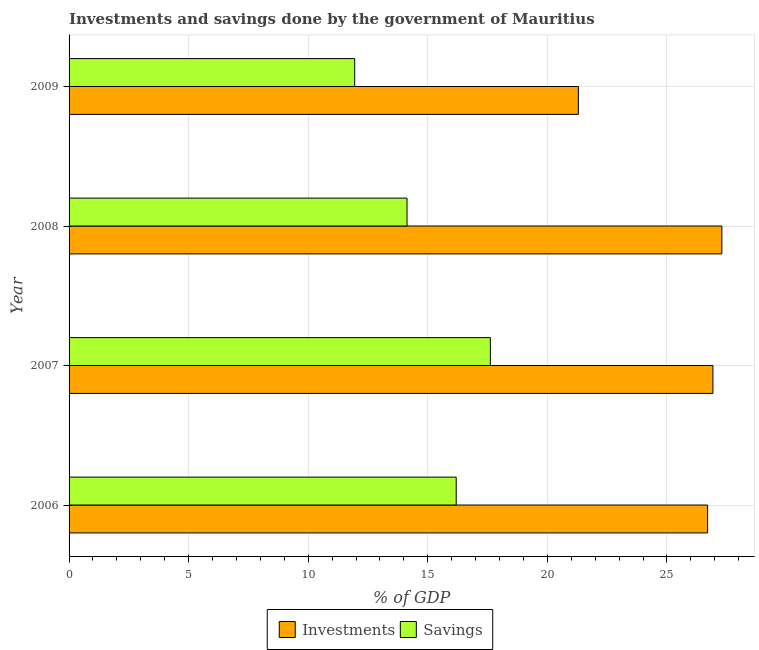How many different coloured bars are there?
Ensure brevity in your answer.  2. In how many cases, is the number of bars for a given year not equal to the number of legend labels?
Your answer should be very brief. 0. What is the investments of government in 2007?
Provide a short and direct response. 26.92. Across all years, what is the maximum savings of government?
Keep it short and to the point. 17.62. Across all years, what is the minimum investments of government?
Give a very brief answer. 21.3. In which year was the savings of government maximum?
Your answer should be compact. 2007. What is the total savings of government in the graph?
Your answer should be very brief. 59.88. What is the difference between the savings of government in 2006 and that in 2008?
Offer a terse response. 2.06. What is the difference between the savings of government in 2008 and the investments of government in 2007?
Your answer should be very brief. -12.79. What is the average savings of government per year?
Give a very brief answer. 14.97. In the year 2009, what is the difference between the investments of government and savings of government?
Your answer should be very brief. 9.35. What is the ratio of the investments of government in 2007 to that in 2009?
Give a very brief answer. 1.26. Is the difference between the investments of government in 2008 and 2009 greater than the difference between the savings of government in 2008 and 2009?
Your response must be concise. Yes. What is the difference between the highest and the second highest savings of government?
Your response must be concise. 1.43. What is the difference between the highest and the lowest savings of government?
Your response must be concise. 5.67. In how many years, is the savings of government greater than the average savings of government taken over all years?
Give a very brief answer. 2. What does the 2nd bar from the top in 2006 represents?
Offer a very short reply. Investments. What does the 1st bar from the bottom in 2006 represents?
Give a very brief answer. Investments. How many bars are there?
Offer a very short reply. 8. Are all the bars in the graph horizontal?
Offer a terse response. Yes. How many years are there in the graph?
Make the answer very short. 4. Are the values on the major ticks of X-axis written in scientific E-notation?
Your response must be concise. No. Does the graph contain any zero values?
Ensure brevity in your answer.  No. Where does the legend appear in the graph?
Your answer should be very brief. Bottom center. How many legend labels are there?
Give a very brief answer. 2. What is the title of the graph?
Keep it short and to the point. Investments and savings done by the government of Mauritius. What is the label or title of the X-axis?
Provide a short and direct response. % of GDP. What is the label or title of the Y-axis?
Provide a succinct answer. Year. What is the % of GDP of Investments in 2006?
Offer a very short reply. 26.7. What is the % of GDP of Savings in 2006?
Provide a short and direct response. 16.19. What is the % of GDP in Investments in 2007?
Offer a very short reply. 26.92. What is the % of GDP in Savings in 2007?
Provide a short and direct response. 17.62. What is the % of GDP of Investments in 2008?
Provide a succinct answer. 27.3. What is the % of GDP of Savings in 2008?
Your response must be concise. 14.13. What is the % of GDP of Investments in 2009?
Keep it short and to the point. 21.3. What is the % of GDP of Savings in 2009?
Provide a succinct answer. 11.94. Across all years, what is the maximum % of GDP in Investments?
Provide a short and direct response. 27.3. Across all years, what is the maximum % of GDP in Savings?
Offer a very short reply. 17.62. Across all years, what is the minimum % of GDP in Investments?
Make the answer very short. 21.3. Across all years, what is the minimum % of GDP of Savings?
Your answer should be very brief. 11.94. What is the total % of GDP in Investments in the graph?
Provide a succinct answer. 102.22. What is the total % of GDP in Savings in the graph?
Your answer should be very brief. 59.88. What is the difference between the % of GDP of Investments in 2006 and that in 2007?
Give a very brief answer. -0.22. What is the difference between the % of GDP of Savings in 2006 and that in 2007?
Make the answer very short. -1.43. What is the difference between the % of GDP in Investments in 2006 and that in 2008?
Ensure brevity in your answer.  -0.6. What is the difference between the % of GDP of Savings in 2006 and that in 2008?
Provide a short and direct response. 2.06. What is the difference between the % of GDP of Investments in 2006 and that in 2009?
Your answer should be very brief. 5.4. What is the difference between the % of GDP of Savings in 2006 and that in 2009?
Offer a very short reply. 4.24. What is the difference between the % of GDP of Investments in 2007 and that in 2008?
Your answer should be compact. -0.37. What is the difference between the % of GDP of Savings in 2007 and that in 2008?
Your answer should be very brief. 3.48. What is the difference between the % of GDP of Investments in 2007 and that in 2009?
Keep it short and to the point. 5.63. What is the difference between the % of GDP of Savings in 2007 and that in 2009?
Your response must be concise. 5.67. What is the difference between the % of GDP in Investments in 2008 and that in 2009?
Ensure brevity in your answer.  6. What is the difference between the % of GDP of Savings in 2008 and that in 2009?
Give a very brief answer. 2.19. What is the difference between the % of GDP in Investments in 2006 and the % of GDP in Savings in 2007?
Your response must be concise. 9.09. What is the difference between the % of GDP of Investments in 2006 and the % of GDP of Savings in 2008?
Offer a very short reply. 12.57. What is the difference between the % of GDP in Investments in 2006 and the % of GDP in Savings in 2009?
Ensure brevity in your answer.  14.76. What is the difference between the % of GDP in Investments in 2007 and the % of GDP in Savings in 2008?
Provide a short and direct response. 12.79. What is the difference between the % of GDP in Investments in 2007 and the % of GDP in Savings in 2009?
Offer a terse response. 14.98. What is the difference between the % of GDP in Investments in 2008 and the % of GDP in Savings in 2009?
Provide a succinct answer. 15.35. What is the average % of GDP of Investments per year?
Keep it short and to the point. 25.56. What is the average % of GDP of Savings per year?
Your response must be concise. 14.97. In the year 2006, what is the difference between the % of GDP of Investments and % of GDP of Savings?
Your answer should be compact. 10.51. In the year 2007, what is the difference between the % of GDP in Investments and % of GDP in Savings?
Give a very brief answer. 9.31. In the year 2008, what is the difference between the % of GDP in Investments and % of GDP in Savings?
Provide a succinct answer. 13.17. In the year 2009, what is the difference between the % of GDP in Investments and % of GDP in Savings?
Offer a very short reply. 9.35. What is the ratio of the % of GDP in Investments in 2006 to that in 2007?
Your response must be concise. 0.99. What is the ratio of the % of GDP of Savings in 2006 to that in 2007?
Your answer should be very brief. 0.92. What is the ratio of the % of GDP of Investments in 2006 to that in 2008?
Give a very brief answer. 0.98. What is the ratio of the % of GDP of Savings in 2006 to that in 2008?
Make the answer very short. 1.15. What is the ratio of the % of GDP in Investments in 2006 to that in 2009?
Your answer should be compact. 1.25. What is the ratio of the % of GDP of Savings in 2006 to that in 2009?
Your answer should be compact. 1.36. What is the ratio of the % of GDP in Investments in 2007 to that in 2008?
Provide a short and direct response. 0.99. What is the ratio of the % of GDP of Savings in 2007 to that in 2008?
Make the answer very short. 1.25. What is the ratio of the % of GDP in Investments in 2007 to that in 2009?
Make the answer very short. 1.26. What is the ratio of the % of GDP in Savings in 2007 to that in 2009?
Offer a terse response. 1.48. What is the ratio of the % of GDP in Investments in 2008 to that in 2009?
Your answer should be very brief. 1.28. What is the ratio of the % of GDP in Savings in 2008 to that in 2009?
Ensure brevity in your answer.  1.18. What is the difference between the highest and the second highest % of GDP in Investments?
Keep it short and to the point. 0.37. What is the difference between the highest and the second highest % of GDP in Savings?
Your answer should be very brief. 1.43. What is the difference between the highest and the lowest % of GDP in Investments?
Offer a terse response. 6. What is the difference between the highest and the lowest % of GDP of Savings?
Keep it short and to the point. 5.67. 